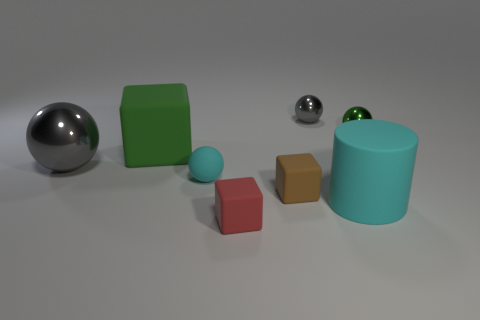Does the big rubber object that is behind the cyan rubber sphere have the same color as the metal ball that is to the right of the big matte cylinder?
Ensure brevity in your answer.  Yes. There is a gray metal sphere behind the small green thing; what number of rubber cubes are behind it?
Your answer should be compact. 0. Are any things visible?
Offer a terse response. Yes. How many other things are the same color as the big cylinder?
Ensure brevity in your answer.  1. Is the number of gray spheres less than the number of rubber cylinders?
Provide a succinct answer. No. There is a small matte object that is in front of the big cyan rubber thing to the right of the small red rubber thing; what is its shape?
Provide a succinct answer. Cube. Are there any small gray metallic objects in front of the tiny cyan object?
Ensure brevity in your answer.  No. There is a rubber cube that is the same size as the cyan rubber cylinder; what color is it?
Provide a succinct answer. Green. What number of big cyan objects are the same material as the big green cube?
Provide a short and direct response. 1. What number of other objects are the same size as the brown matte cube?
Provide a succinct answer. 4. 